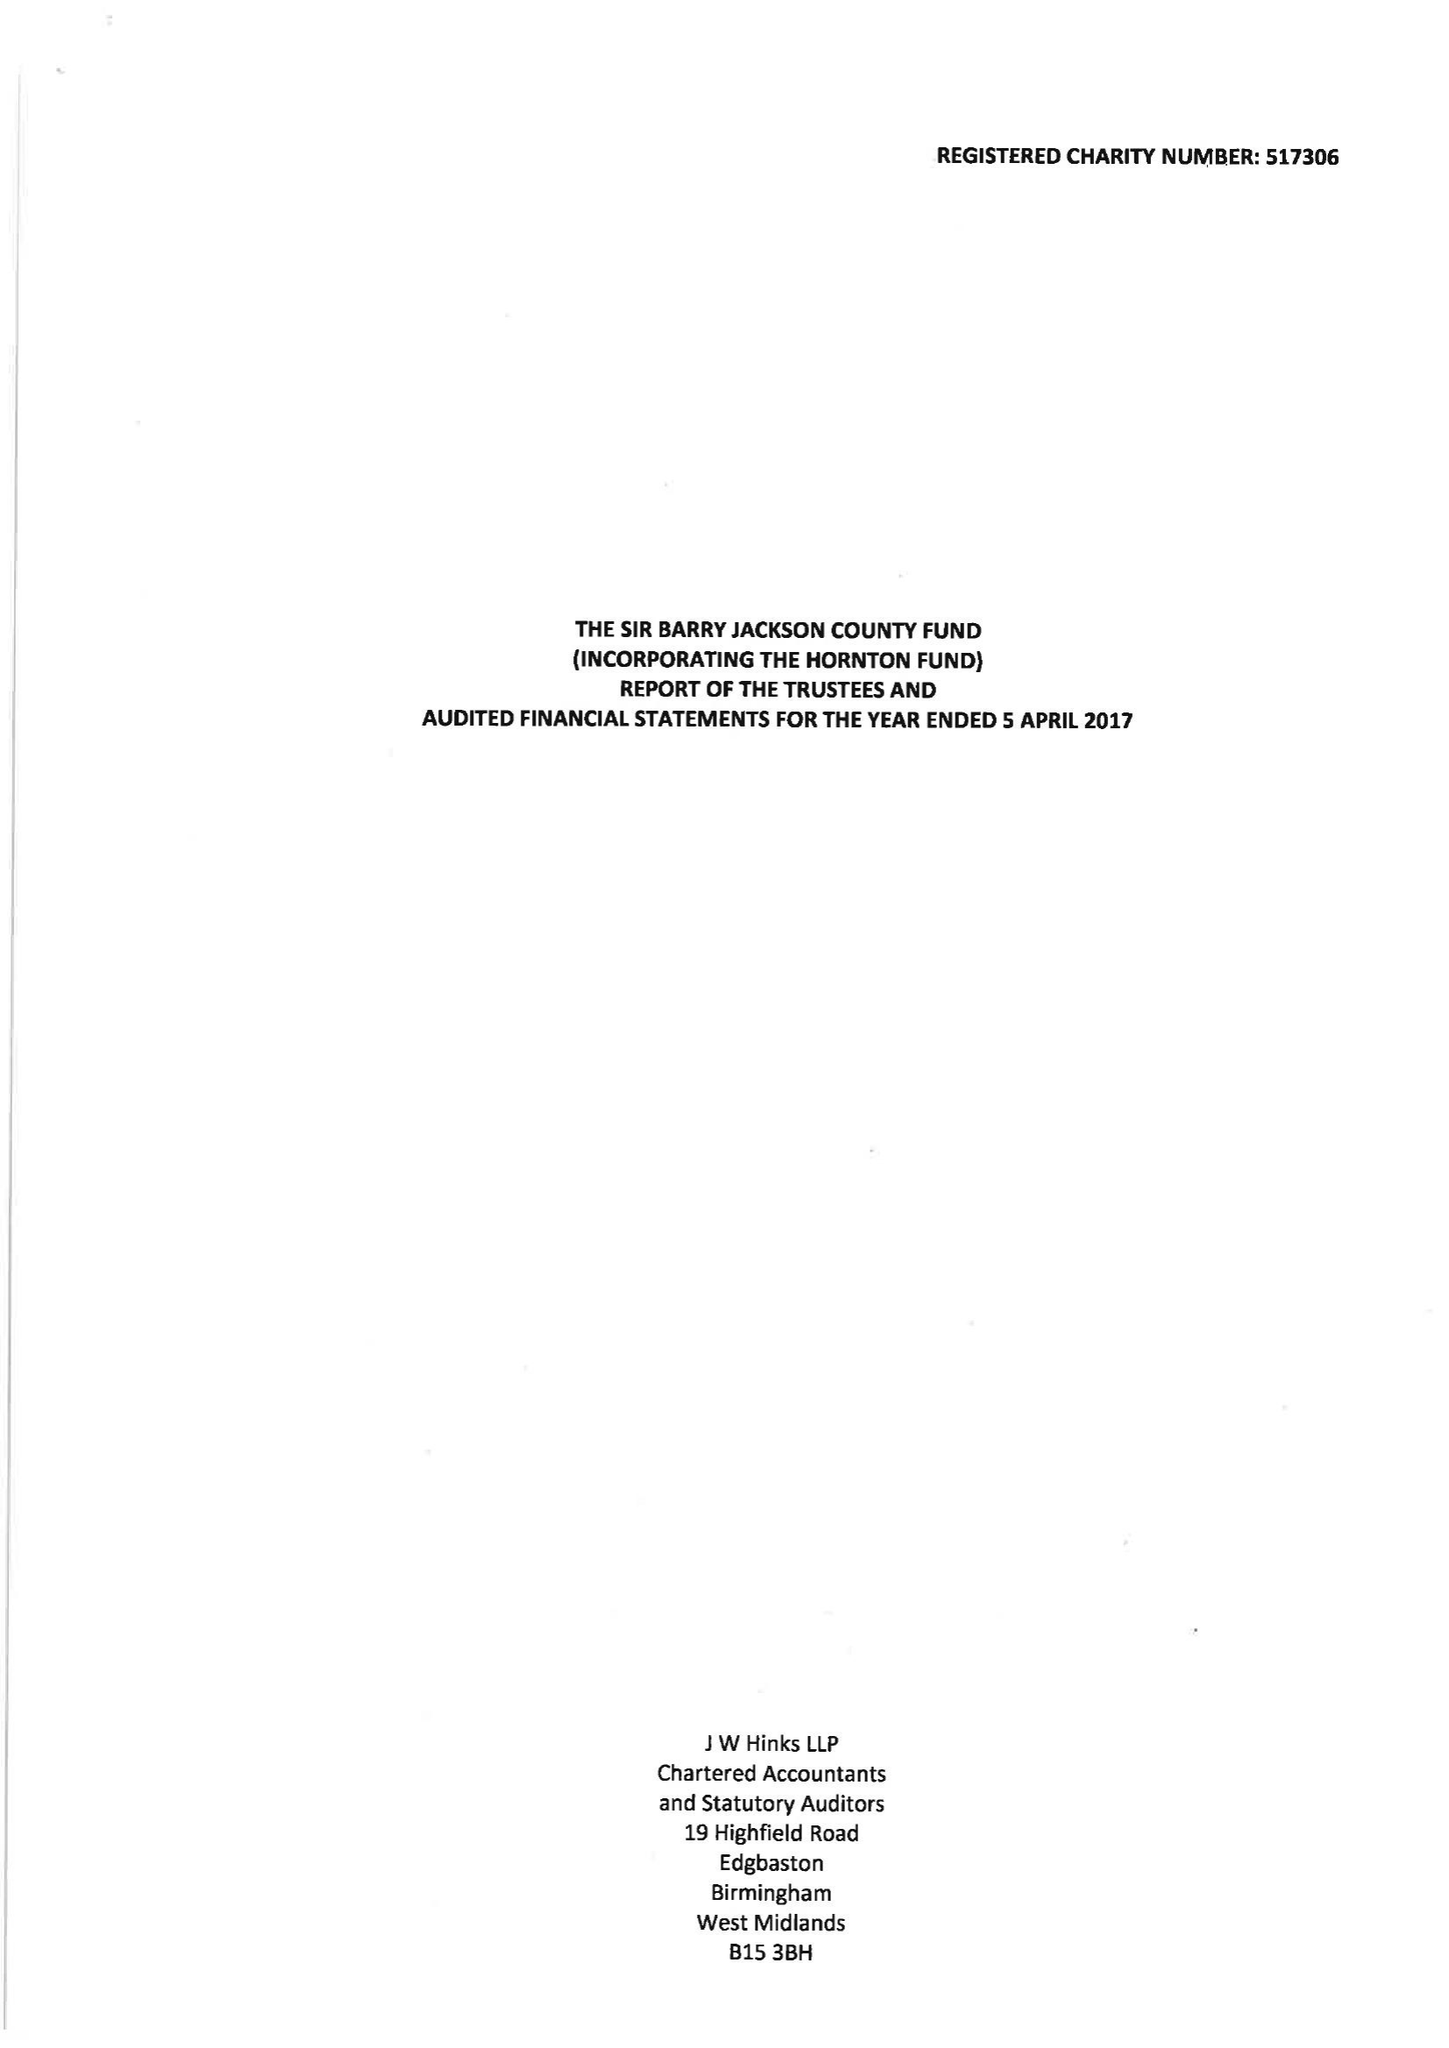What is the value for the address__postcode?
Answer the question using a single word or phrase. B1 2EP 